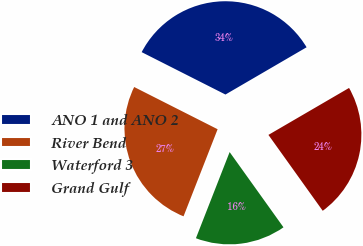Convert chart. <chart><loc_0><loc_0><loc_500><loc_500><pie_chart><fcel>ANO 1 and ANO 2<fcel>River Bend<fcel>Waterford 3<fcel>Grand Gulf<nl><fcel>34.15%<fcel>26.52%<fcel>15.82%<fcel>23.51%<nl></chart> 